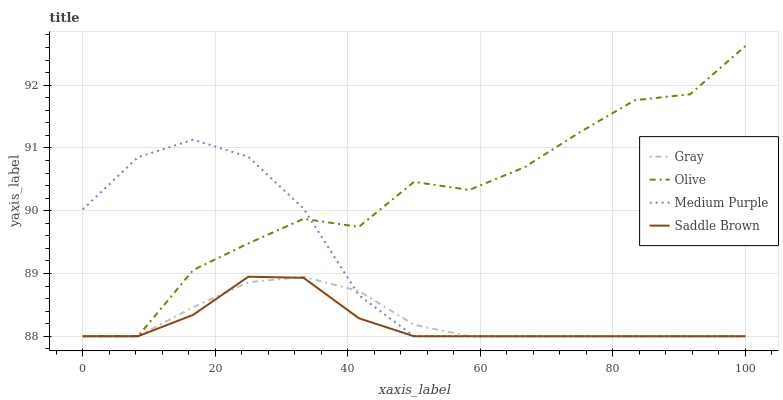Does Saddle Brown have the minimum area under the curve?
Answer yes or no. Yes. Does Olive have the maximum area under the curve?
Answer yes or no. Yes. Does Gray have the minimum area under the curve?
Answer yes or no. No. Does Gray have the maximum area under the curve?
Answer yes or no. No. Is Gray the smoothest?
Answer yes or no. Yes. Is Olive the roughest?
Answer yes or no. Yes. Is Medium Purple the smoothest?
Answer yes or no. No. Is Medium Purple the roughest?
Answer yes or no. No. Does Olive have the lowest value?
Answer yes or no. Yes. Does Olive have the highest value?
Answer yes or no. Yes. Does Medium Purple have the highest value?
Answer yes or no. No. Does Saddle Brown intersect Gray?
Answer yes or no. Yes. Is Saddle Brown less than Gray?
Answer yes or no. No. Is Saddle Brown greater than Gray?
Answer yes or no. No. 